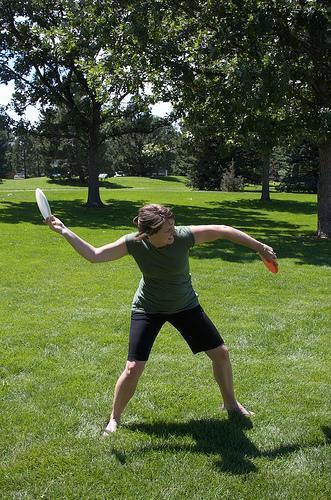How many girls are there?
Give a very brief answer. 1. How many cars are to the left of the carriage?
Give a very brief answer. 0. 